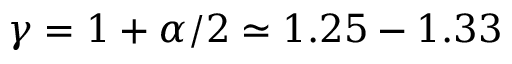<formula> <loc_0><loc_0><loc_500><loc_500>\gamma = 1 + \alpha / 2 \simeq 1 . 2 5 - 1 . 3 3</formula> 